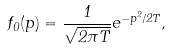<formula> <loc_0><loc_0><loc_500><loc_500>f _ { 0 } ( p ) = \frac { 1 } { \sqrt { 2 \pi T } } e ^ { - p ^ { 2 } / 2 T } ,</formula> 